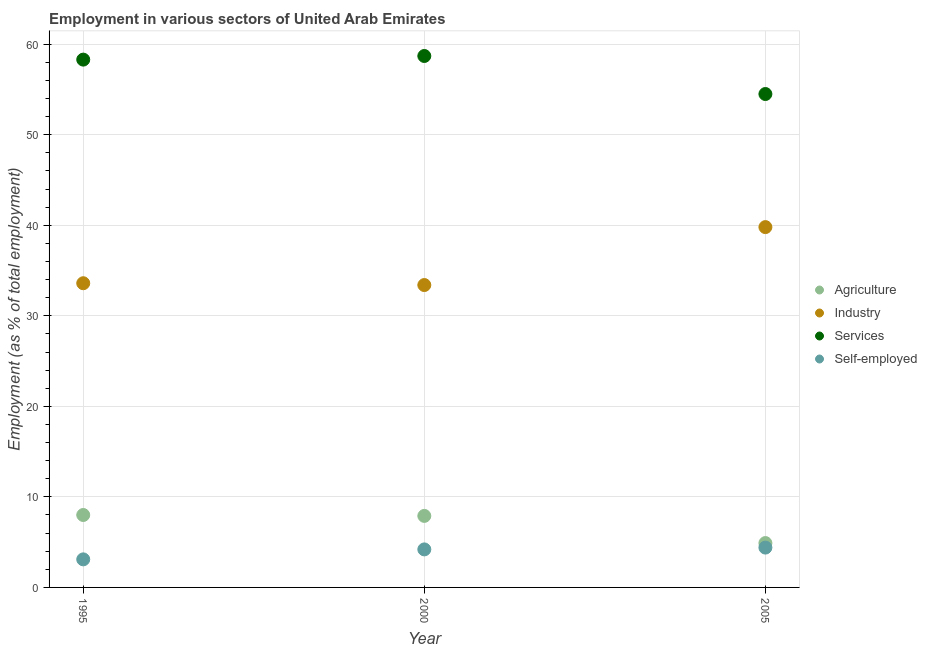How many different coloured dotlines are there?
Ensure brevity in your answer.  4. Is the number of dotlines equal to the number of legend labels?
Your answer should be very brief. Yes. What is the percentage of workers in services in 2005?
Ensure brevity in your answer.  54.5. Across all years, what is the minimum percentage of self employed workers?
Give a very brief answer. 3.1. What is the total percentage of workers in services in the graph?
Your response must be concise. 171.5. What is the difference between the percentage of workers in industry in 1995 and that in 2000?
Your response must be concise. 0.2. What is the difference between the percentage of workers in services in 2000 and the percentage of workers in industry in 2005?
Provide a short and direct response. 18.9. What is the average percentage of workers in services per year?
Offer a terse response. 57.17. In the year 1995, what is the difference between the percentage of workers in industry and percentage of self employed workers?
Your answer should be compact. 30.5. In how many years, is the percentage of self employed workers greater than 12 %?
Give a very brief answer. 0. What is the ratio of the percentage of workers in industry in 1995 to that in 2005?
Make the answer very short. 0.84. Is the percentage of self employed workers in 2000 less than that in 2005?
Your response must be concise. Yes. What is the difference between the highest and the second highest percentage of workers in agriculture?
Your answer should be very brief. 0.1. What is the difference between the highest and the lowest percentage of workers in industry?
Offer a very short reply. 6.4. Is it the case that in every year, the sum of the percentage of self employed workers and percentage of workers in industry is greater than the sum of percentage of workers in services and percentage of workers in agriculture?
Make the answer very short. Yes. Does the percentage of self employed workers monotonically increase over the years?
Offer a terse response. Yes. Is the percentage of workers in industry strictly less than the percentage of self employed workers over the years?
Provide a succinct answer. No. How many years are there in the graph?
Provide a short and direct response. 3. What is the difference between two consecutive major ticks on the Y-axis?
Your answer should be very brief. 10. Does the graph contain any zero values?
Provide a short and direct response. No. Does the graph contain grids?
Ensure brevity in your answer.  Yes. How are the legend labels stacked?
Offer a very short reply. Vertical. What is the title of the graph?
Make the answer very short. Employment in various sectors of United Arab Emirates. What is the label or title of the X-axis?
Your answer should be very brief. Year. What is the label or title of the Y-axis?
Ensure brevity in your answer.  Employment (as % of total employment). What is the Employment (as % of total employment) in Agriculture in 1995?
Offer a very short reply. 8. What is the Employment (as % of total employment) in Industry in 1995?
Your answer should be compact. 33.6. What is the Employment (as % of total employment) in Services in 1995?
Your response must be concise. 58.3. What is the Employment (as % of total employment) of Self-employed in 1995?
Your response must be concise. 3.1. What is the Employment (as % of total employment) in Agriculture in 2000?
Provide a succinct answer. 7.9. What is the Employment (as % of total employment) of Industry in 2000?
Keep it short and to the point. 33.4. What is the Employment (as % of total employment) of Services in 2000?
Your answer should be very brief. 58.7. What is the Employment (as % of total employment) of Self-employed in 2000?
Your answer should be very brief. 4.2. What is the Employment (as % of total employment) in Agriculture in 2005?
Offer a very short reply. 4.9. What is the Employment (as % of total employment) in Industry in 2005?
Give a very brief answer. 39.8. What is the Employment (as % of total employment) of Services in 2005?
Your response must be concise. 54.5. What is the Employment (as % of total employment) of Self-employed in 2005?
Offer a very short reply. 4.4. Across all years, what is the maximum Employment (as % of total employment) of Industry?
Offer a very short reply. 39.8. Across all years, what is the maximum Employment (as % of total employment) in Services?
Your response must be concise. 58.7. Across all years, what is the maximum Employment (as % of total employment) in Self-employed?
Give a very brief answer. 4.4. Across all years, what is the minimum Employment (as % of total employment) of Agriculture?
Offer a terse response. 4.9. Across all years, what is the minimum Employment (as % of total employment) of Industry?
Ensure brevity in your answer.  33.4. Across all years, what is the minimum Employment (as % of total employment) of Services?
Provide a short and direct response. 54.5. Across all years, what is the minimum Employment (as % of total employment) of Self-employed?
Provide a succinct answer. 3.1. What is the total Employment (as % of total employment) of Agriculture in the graph?
Your answer should be compact. 20.8. What is the total Employment (as % of total employment) in Industry in the graph?
Keep it short and to the point. 106.8. What is the total Employment (as % of total employment) of Services in the graph?
Your answer should be compact. 171.5. What is the difference between the Employment (as % of total employment) in Agriculture in 1995 and that in 2000?
Make the answer very short. 0.1. What is the difference between the Employment (as % of total employment) of Industry in 1995 and that in 2000?
Your answer should be compact. 0.2. What is the difference between the Employment (as % of total employment) in Services in 1995 and that in 2000?
Keep it short and to the point. -0.4. What is the difference between the Employment (as % of total employment) in Industry in 1995 and that in 2005?
Your response must be concise. -6.2. What is the difference between the Employment (as % of total employment) of Services in 1995 and that in 2005?
Provide a succinct answer. 3.8. What is the difference between the Employment (as % of total employment) in Industry in 2000 and that in 2005?
Your answer should be compact. -6.4. What is the difference between the Employment (as % of total employment) of Agriculture in 1995 and the Employment (as % of total employment) of Industry in 2000?
Your answer should be very brief. -25.4. What is the difference between the Employment (as % of total employment) in Agriculture in 1995 and the Employment (as % of total employment) in Services in 2000?
Keep it short and to the point. -50.7. What is the difference between the Employment (as % of total employment) of Industry in 1995 and the Employment (as % of total employment) of Services in 2000?
Your answer should be very brief. -25.1. What is the difference between the Employment (as % of total employment) of Industry in 1995 and the Employment (as % of total employment) of Self-employed in 2000?
Make the answer very short. 29.4. What is the difference between the Employment (as % of total employment) in Services in 1995 and the Employment (as % of total employment) in Self-employed in 2000?
Ensure brevity in your answer.  54.1. What is the difference between the Employment (as % of total employment) of Agriculture in 1995 and the Employment (as % of total employment) of Industry in 2005?
Provide a short and direct response. -31.8. What is the difference between the Employment (as % of total employment) of Agriculture in 1995 and the Employment (as % of total employment) of Services in 2005?
Keep it short and to the point. -46.5. What is the difference between the Employment (as % of total employment) in Industry in 1995 and the Employment (as % of total employment) in Services in 2005?
Keep it short and to the point. -20.9. What is the difference between the Employment (as % of total employment) of Industry in 1995 and the Employment (as % of total employment) of Self-employed in 2005?
Provide a succinct answer. 29.2. What is the difference between the Employment (as % of total employment) of Services in 1995 and the Employment (as % of total employment) of Self-employed in 2005?
Offer a terse response. 53.9. What is the difference between the Employment (as % of total employment) in Agriculture in 2000 and the Employment (as % of total employment) in Industry in 2005?
Your answer should be compact. -31.9. What is the difference between the Employment (as % of total employment) of Agriculture in 2000 and the Employment (as % of total employment) of Services in 2005?
Your answer should be very brief. -46.6. What is the difference between the Employment (as % of total employment) in Industry in 2000 and the Employment (as % of total employment) in Services in 2005?
Give a very brief answer. -21.1. What is the difference between the Employment (as % of total employment) in Services in 2000 and the Employment (as % of total employment) in Self-employed in 2005?
Your answer should be compact. 54.3. What is the average Employment (as % of total employment) of Agriculture per year?
Provide a succinct answer. 6.93. What is the average Employment (as % of total employment) of Industry per year?
Your answer should be compact. 35.6. What is the average Employment (as % of total employment) in Services per year?
Your answer should be very brief. 57.17. In the year 1995, what is the difference between the Employment (as % of total employment) of Agriculture and Employment (as % of total employment) of Industry?
Provide a short and direct response. -25.6. In the year 1995, what is the difference between the Employment (as % of total employment) in Agriculture and Employment (as % of total employment) in Services?
Offer a very short reply. -50.3. In the year 1995, what is the difference between the Employment (as % of total employment) in Industry and Employment (as % of total employment) in Services?
Keep it short and to the point. -24.7. In the year 1995, what is the difference between the Employment (as % of total employment) in Industry and Employment (as % of total employment) in Self-employed?
Give a very brief answer. 30.5. In the year 1995, what is the difference between the Employment (as % of total employment) in Services and Employment (as % of total employment) in Self-employed?
Your answer should be compact. 55.2. In the year 2000, what is the difference between the Employment (as % of total employment) in Agriculture and Employment (as % of total employment) in Industry?
Your answer should be compact. -25.5. In the year 2000, what is the difference between the Employment (as % of total employment) in Agriculture and Employment (as % of total employment) in Services?
Offer a terse response. -50.8. In the year 2000, what is the difference between the Employment (as % of total employment) of Agriculture and Employment (as % of total employment) of Self-employed?
Provide a short and direct response. 3.7. In the year 2000, what is the difference between the Employment (as % of total employment) of Industry and Employment (as % of total employment) of Services?
Your answer should be very brief. -25.3. In the year 2000, what is the difference between the Employment (as % of total employment) of Industry and Employment (as % of total employment) of Self-employed?
Give a very brief answer. 29.2. In the year 2000, what is the difference between the Employment (as % of total employment) in Services and Employment (as % of total employment) in Self-employed?
Offer a very short reply. 54.5. In the year 2005, what is the difference between the Employment (as % of total employment) of Agriculture and Employment (as % of total employment) of Industry?
Make the answer very short. -34.9. In the year 2005, what is the difference between the Employment (as % of total employment) in Agriculture and Employment (as % of total employment) in Services?
Provide a succinct answer. -49.6. In the year 2005, what is the difference between the Employment (as % of total employment) in Industry and Employment (as % of total employment) in Services?
Ensure brevity in your answer.  -14.7. In the year 2005, what is the difference between the Employment (as % of total employment) of Industry and Employment (as % of total employment) of Self-employed?
Ensure brevity in your answer.  35.4. In the year 2005, what is the difference between the Employment (as % of total employment) of Services and Employment (as % of total employment) of Self-employed?
Your answer should be compact. 50.1. What is the ratio of the Employment (as % of total employment) of Agriculture in 1995 to that in 2000?
Ensure brevity in your answer.  1.01. What is the ratio of the Employment (as % of total employment) of Industry in 1995 to that in 2000?
Keep it short and to the point. 1.01. What is the ratio of the Employment (as % of total employment) in Self-employed in 1995 to that in 2000?
Your response must be concise. 0.74. What is the ratio of the Employment (as % of total employment) in Agriculture in 1995 to that in 2005?
Ensure brevity in your answer.  1.63. What is the ratio of the Employment (as % of total employment) in Industry in 1995 to that in 2005?
Give a very brief answer. 0.84. What is the ratio of the Employment (as % of total employment) in Services in 1995 to that in 2005?
Make the answer very short. 1.07. What is the ratio of the Employment (as % of total employment) in Self-employed in 1995 to that in 2005?
Provide a short and direct response. 0.7. What is the ratio of the Employment (as % of total employment) in Agriculture in 2000 to that in 2005?
Your response must be concise. 1.61. What is the ratio of the Employment (as % of total employment) of Industry in 2000 to that in 2005?
Provide a succinct answer. 0.84. What is the ratio of the Employment (as % of total employment) in Services in 2000 to that in 2005?
Offer a very short reply. 1.08. What is the ratio of the Employment (as % of total employment) of Self-employed in 2000 to that in 2005?
Your answer should be compact. 0.95. What is the difference between the highest and the second highest Employment (as % of total employment) of Agriculture?
Provide a succinct answer. 0.1. What is the difference between the highest and the second highest Employment (as % of total employment) in Industry?
Your answer should be compact. 6.2. What is the difference between the highest and the lowest Employment (as % of total employment) of Industry?
Offer a very short reply. 6.4. What is the difference between the highest and the lowest Employment (as % of total employment) of Services?
Provide a short and direct response. 4.2. What is the difference between the highest and the lowest Employment (as % of total employment) in Self-employed?
Provide a short and direct response. 1.3. 